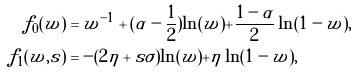Convert formula to latex. <formula><loc_0><loc_0><loc_500><loc_500>f _ { 0 } ( w ) & = w ^ { - 1 } + ( \alpha - \frac { 1 } { 2 } ) \ln ( w ) + \frac { 1 - \alpha } { 2 } \ln ( 1 - w ) , \\ f _ { 1 } ( w , s ) & = - ( 2 \eta + s \sigma ) \ln ( w ) + \eta \ln ( 1 - w ) ,</formula> 